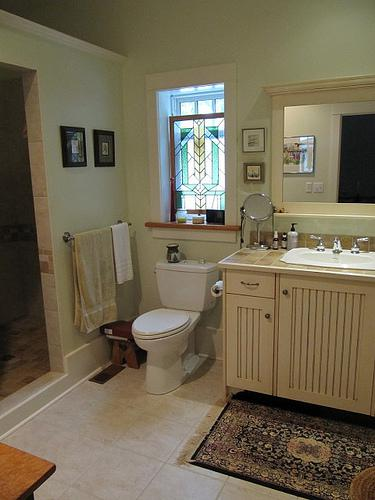Question: where is the mirror?
Choices:
A. Right.
B. Left.
C. Center.
D. In the bathroom.
Answer with the letter. Answer: A Question: what is this room?
Choices:
A. Living room.
B. Dining room.
C. Den.
D. Bathroom.
Answer with the letter. Answer: D Question: how is the towel placed?
Choices:
A. On the floor.
B. On a rack.
C. In the closet.
D. Under the vanity.
Answer with the letter. Answer: B Question: where are the black picture frames?
Choices:
A. Wall.
B. Desk.
C. Table.
D. End table.
Answer with the letter. Answer: A 